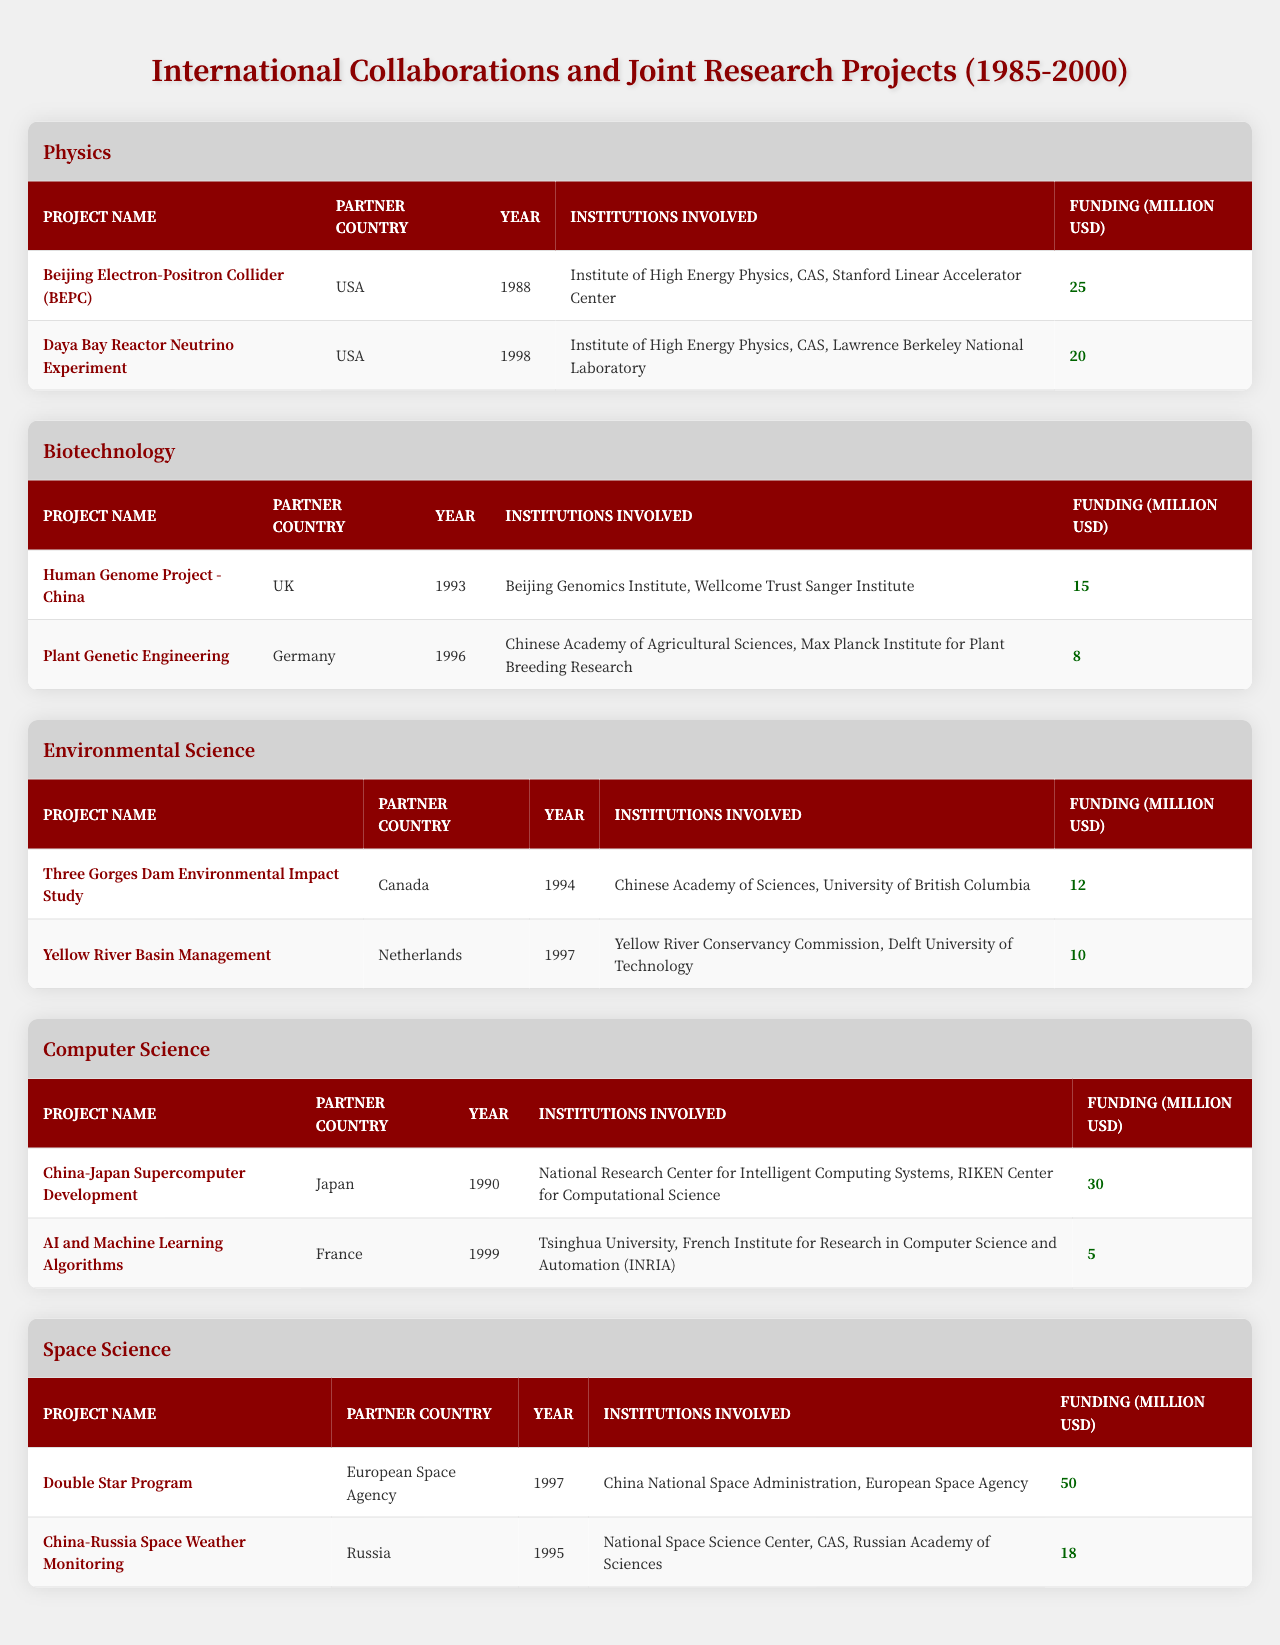What is the total funding for the projects in the field of Physics? There are two projects in Physics: the Beijing Electron-Positron Collider with funding of 25 million USD and the Daya Bay Reactor Neutrino Experiment with funding of 20 million USD. Summing these amounts gives 25 + 20 = 45 million USD.
Answer: 45 million USD Which country partnered with China for the Human Genome Project? The Human Genome Project - China had the UK as its partner country, as stated in the table.
Answer: UK What was the average funding for the Environmental Science projects? There are two Environmental Science projects: the Three Gorges Dam Environmental Impact Study with 12 million USD, and the Yellow River Basin Management with 10 million USD. Adding these gives 12 + 10 = 22 million USD, and dividing by 2 gives an average of 22 / 2 = 11 million USD.
Answer: 11 million USD Is the funding for the China-Japan Supercomputer Development greater than the total funding for both Biotechnology projects? The China-Japan Supercomputer Development project received 30 million USD, while the two Biotechnology projects received 15 million USD and 8 million USD respectively (totaling 15 + 8 = 23 million USD). Since 30 million is greater than 23 million, the answer is yes.
Answer: Yes How many projects did China collaborate on with the USA and what was their total funding? China collaborated on three projects with the USA: the Beijing Electron-Positron Collider (25 million USD), the Daya Bay Reactor Neutrino Experiment (20 million USD), and the China-Russia Space Weather Monitoring (18 million USD). The total funding for these three projects is 25 + 20 + 18 = 63 million USD.
Answer: 3 projects, 63 million USD Which project had the highest funding and what was its amount? The project with the highest funding is the Double Star Program, which received 50 million USD as mentioned in the table.
Answer: Double Star Program, 50 million USD What is the total number of collaborative projects across all fields listed in the table? By counting the projects, there are a total of 10 projects listed in the table across various fields: 2 in Physics, 2 in Biotechnology, 2 in Environmental Science, 2 in Computer Science, and 2 in Space Science. Thus, the total is 2 + 2 + 2 + 2 + 2 = 10 projects.
Answer: 10 projects Which country had the least funding for their joint project with China? The project with the least funding is the AI and Machine Learning Algorithms project with France, which received 5 million USD, as seen in the table.
Answer: France, 5 million USD From which countries did China receive the most funding for their collaborations? The project with the most funding comes from the European Space Agency for the Double Star Program, totaling 50 million USD, followed by Japan's China-Japan Supercomputer Development at 30 million USD. Thus, the countries providing the most funding are the European Space Agency and Japan.
Answer: European Space Agency, Japan What year did the Plant Genetic Engineering project take place? The Plant Genetic Engineering project with Germany occurred in 1996, according to the table.
Answer: 1996 How many projects were initiated in the 1990s (1990-1999) and what was their cumulative funding? The projects from the 1990s include: China-Japan Supercomputer Development (30 million USD, 1990), Human Genome Project - China (15 million USD, 1993), Three Gorges Dam Environmental Impact Study (12 million USD, 1994), China-Russia Space Weather Monitoring (18 million USD, 1995), and AI and Machine Learning Algorithms (5 million USD, 1999). The cumulative funding is 30 + 15 + 12 + 18 + 5 = 80 million USD, totaling 5 projects.
Answer: 5 projects, 80 million USD 